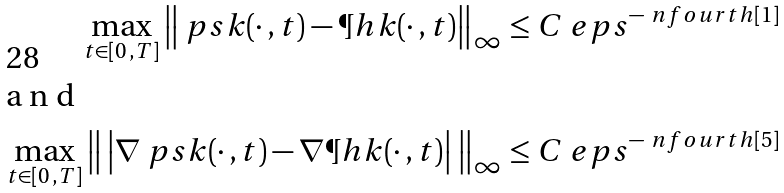Convert formula to latex. <formula><loc_0><loc_0><loc_500><loc_500>\max _ { t \in [ 0 \, , T ] } \left \| \ p s k ( \cdot \, , t ) - \P h k ( \cdot \, , t ) \right \| _ { \infty } \leq C \ e p s ^ { - \ n f o u r t h [ 1 ] } \\ \intertext { a n d } \max _ { t \in [ 0 \, , T ] } \left \| \, \left | \nabla \ p s k ( \cdot \, , t ) - \nabla \P h k ( \cdot \, , t ) \right | \, \right \| _ { \infty } \leq C \ e p s ^ { - \ n f o u r t h [ 5 ] }</formula> 